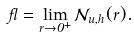<formula> <loc_0><loc_0><loc_500><loc_500>\gamma = \lim _ { r \to 0 ^ { + } } { \mathcal { N } } _ { u , h } ( r ) .</formula> 